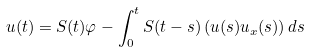<formula> <loc_0><loc_0><loc_500><loc_500>u ( t ) = S ( t ) \varphi - \int _ { 0 } ^ { t } S ( t - s ) \left ( u ( s ) u _ { x } ( s ) \right ) d s</formula> 